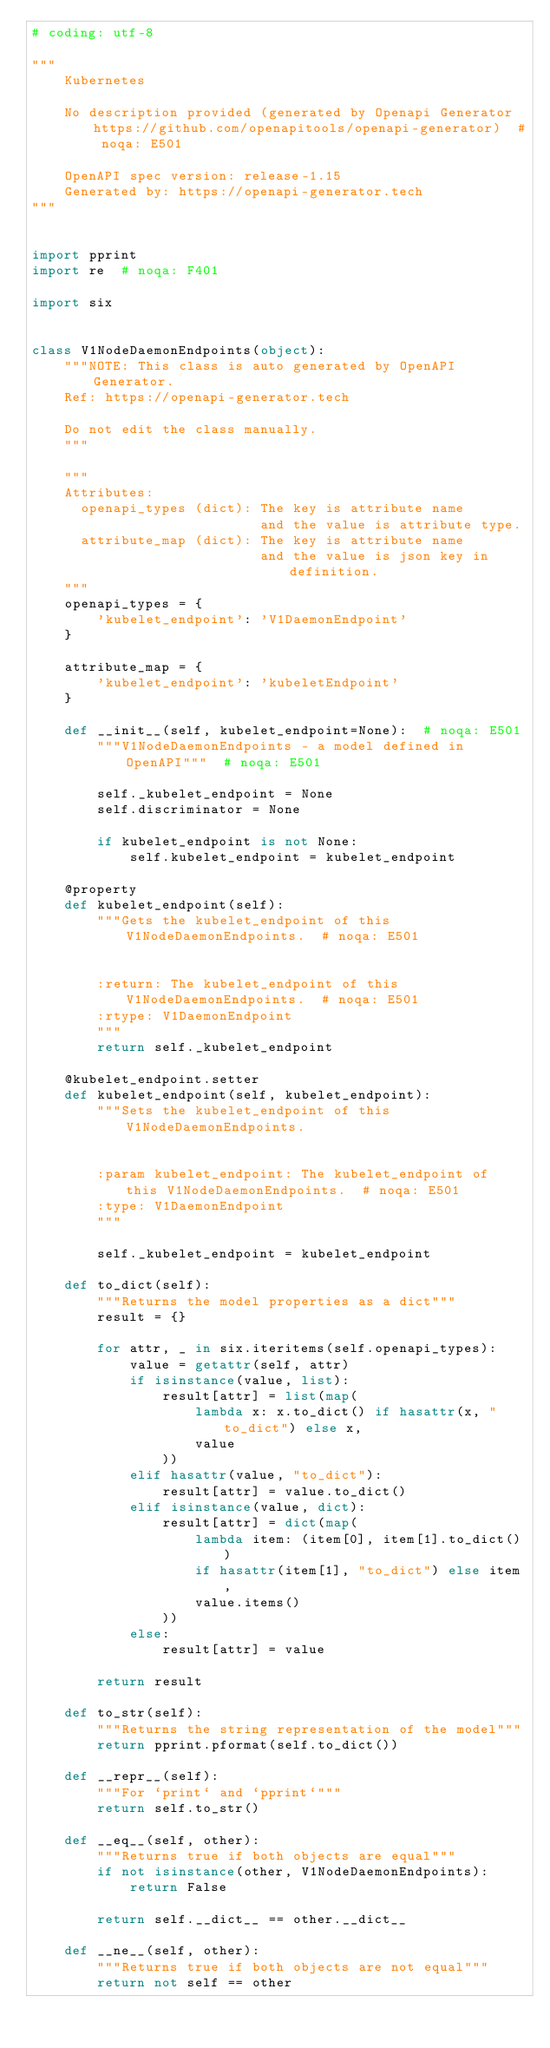<code> <loc_0><loc_0><loc_500><loc_500><_Python_># coding: utf-8

"""
    Kubernetes

    No description provided (generated by Openapi Generator https://github.com/openapitools/openapi-generator)  # noqa: E501

    OpenAPI spec version: release-1.15
    Generated by: https://openapi-generator.tech
"""


import pprint
import re  # noqa: F401

import six


class V1NodeDaemonEndpoints(object):
    """NOTE: This class is auto generated by OpenAPI Generator.
    Ref: https://openapi-generator.tech

    Do not edit the class manually.
    """

    """
    Attributes:
      openapi_types (dict): The key is attribute name
                            and the value is attribute type.
      attribute_map (dict): The key is attribute name
                            and the value is json key in definition.
    """
    openapi_types = {
        'kubelet_endpoint': 'V1DaemonEndpoint'
    }

    attribute_map = {
        'kubelet_endpoint': 'kubeletEndpoint'
    }

    def __init__(self, kubelet_endpoint=None):  # noqa: E501
        """V1NodeDaemonEndpoints - a model defined in OpenAPI"""  # noqa: E501

        self._kubelet_endpoint = None
        self.discriminator = None

        if kubelet_endpoint is not None:
            self.kubelet_endpoint = kubelet_endpoint

    @property
    def kubelet_endpoint(self):
        """Gets the kubelet_endpoint of this V1NodeDaemonEndpoints.  # noqa: E501


        :return: The kubelet_endpoint of this V1NodeDaemonEndpoints.  # noqa: E501
        :rtype: V1DaemonEndpoint
        """
        return self._kubelet_endpoint

    @kubelet_endpoint.setter
    def kubelet_endpoint(self, kubelet_endpoint):
        """Sets the kubelet_endpoint of this V1NodeDaemonEndpoints.


        :param kubelet_endpoint: The kubelet_endpoint of this V1NodeDaemonEndpoints.  # noqa: E501
        :type: V1DaemonEndpoint
        """

        self._kubelet_endpoint = kubelet_endpoint

    def to_dict(self):
        """Returns the model properties as a dict"""
        result = {}

        for attr, _ in six.iteritems(self.openapi_types):
            value = getattr(self, attr)
            if isinstance(value, list):
                result[attr] = list(map(
                    lambda x: x.to_dict() if hasattr(x, "to_dict") else x,
                    value
                ))
            elif hasattr(value, "to_dict"):
                result[attr] = value.to_dict()
            elif isinstance(value, dict):
                result[attr] = dict(map(
                    lambda item: (item[0], item[1].to_dict())
                    if hasattr(item[1], "to_dict") else item,
                    value.items()
                ))
            else:
                result[attr] = value

        return result

    def to_str(self):
        """Returns the string representation of the model"""
        return pprint.pformat(self.to_dict())

    def __repr__(self):
        """For `print` and `pprint`"""
        return self.to_str()

    def __eq__(self, other):
        """Returns true if both objects are equal"""
        if not isinstance(other, V1NodeDaemonEndpoints):
            return False

        return self.__dict__ == other.__dict__

    def __ne__(self, other):
        """Returns true if both objects are not equal"""
        return not self == other
</code> 